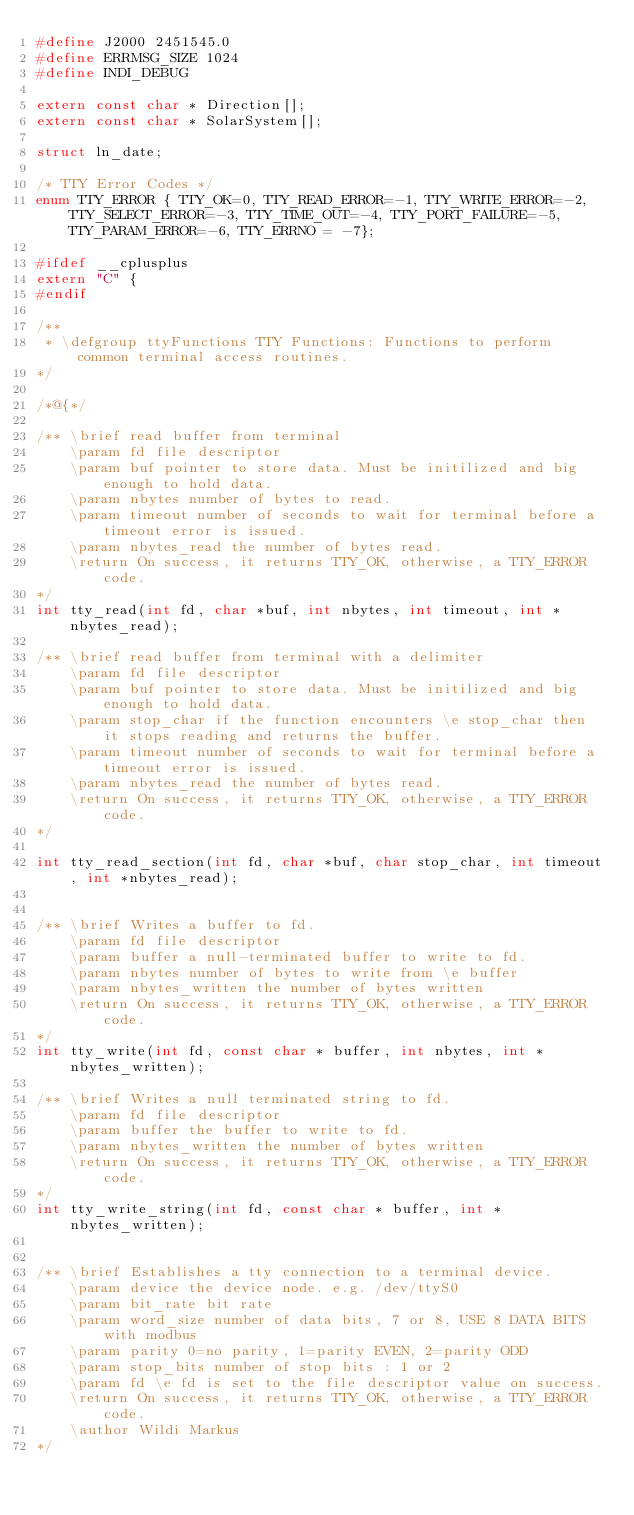<code> <loc_0><loc_0><loc_500><loc_500><_C_>#define J2000 2451545.0
#define ERRMSG_SIZE 1024
#define INDI_DEBUG

extern const char * Direction[];
extern const char * SolarSystem[];

struct ln_date;

/* TTY Error Codes */
enum TTY_ERROR { TTY_OK=0, TTY_READ_ERROR=-1, TTY_WRITE_ERROR=-2, TTY_SELECT_ERROR=-3, TTY_TIME_OUT=-4, TTY_PORT_FAILURE=-5, TTY_PARAM_ERROR=-6, TTY_ERRNO = -7};

#ifdef __cplusplus
extern "C" {
#endif

/**
 * \defgroup ttyFunctions TTY Functions: Functions to perform common terminal access routines.
*/

/*@{*/

/** \brief read buffer from terminal
    \param fd file descriptor
    \param buf pointer to store data. Must be initilized and big enough to hold data.
    \param nbytes number of bytes to read.
    \param timeout number of seconds to wait for terminal before a timeout error is issued.
    \param nbytes_read the number of bytes read.
    \return On success, it returns TTY_OK, otherwise, a TTY_ERROR code.
*/
int tty_read(int fd, char *buf, int nbytes, int timeout, int *nbytes_read);

/** \brief read buffer from terminal with a delimiter
    \param fd file descriptor
    \param buf pointer to store data. Must be initilized and big enough to hold data.
    \param stop_char if the function encounters \e stop_char then it stops reading and returns the buffer.
    \param timeout number of seconds to wait for terminal before a timeout error is issued.
    \param nbytes_read the number of bytes read.
    \return On success, it returns TTY_OK, otherwise, a TTY_ERROR code.
*/

int tty_read_section(int fd, char *buf, char stop_char, int timeout, int *nbytes_read);


/** \brief Writes a buffer to fd.
    \param fd file descriptor
    \param buffer a null-terminated buffer to write to fd.
    \param nbytes number of bytes to write from \e buffer
    \param nbytes_written the number of bytes written
    \return On success, it returns TTY_OK, otherwise, a TTY_ERROR code.
*/
int tty_write(int fd, const char * buffer, int nbytes, int *nbytes_written);

/** \brief Writes a null terminated string to fd.
    \param fd file descriptor
    \param buffer the buffer to write to fd.
    \param nbytes_written the number of bytes written
    \return On success, it returns TTY_OK, otherwise, a TTY_ERROR code.
*/
int tty_write_string(int fd, const char * buffer, int *nbytes_written);


/** \brief Establishes a tty connection to a terminal device.
    \param device the device node. e.g. /dev/ttyS0
    \param bit_rate bit rate
    \param word_size number of data bits, 7 or 8, USE 8 DATA BITS with modbus
    \param parity 0=no parity, 1=parity EVEN, 2=parity ODD
    \param stop_bits number of stop bits : 1 or 2
    \param fd \e fd is set to the file descriptor value on success.
    \return On success, it returns TTY_OK, otherwise, a TTY_ERROR code.
    \author Wildi Markus
*/
</code> 